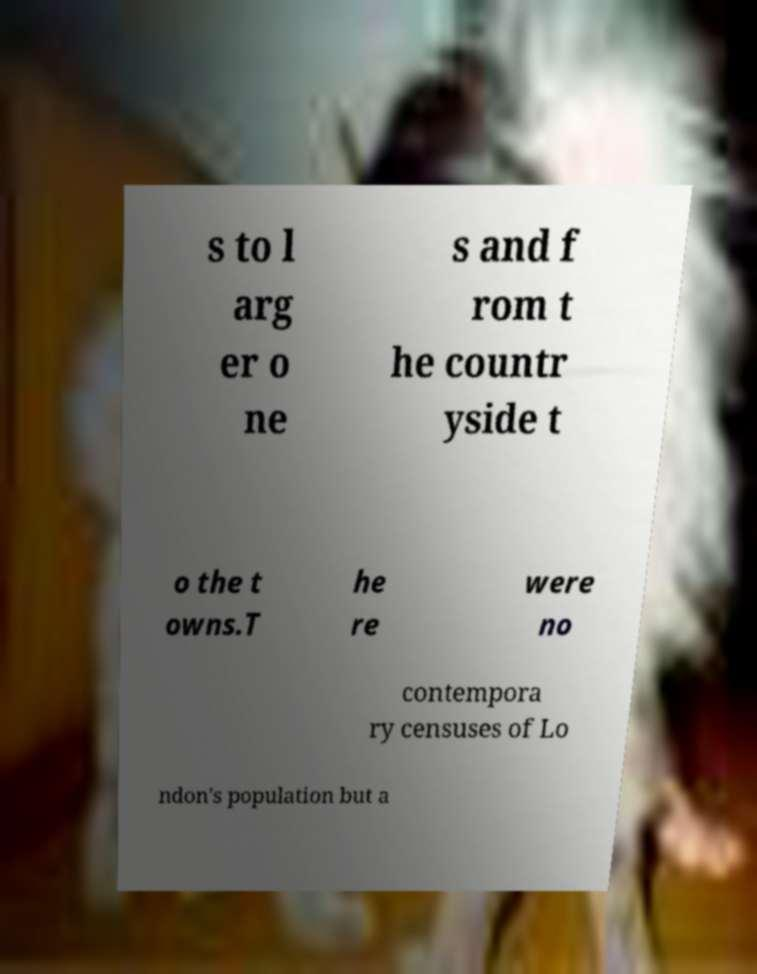I need the written content from this picture converted into text. Can you do that? s to l arg er o ne s and f rom t he countr yside t o the t owns.T he re were no contempora ry censuses of Lo ndon's population but a 